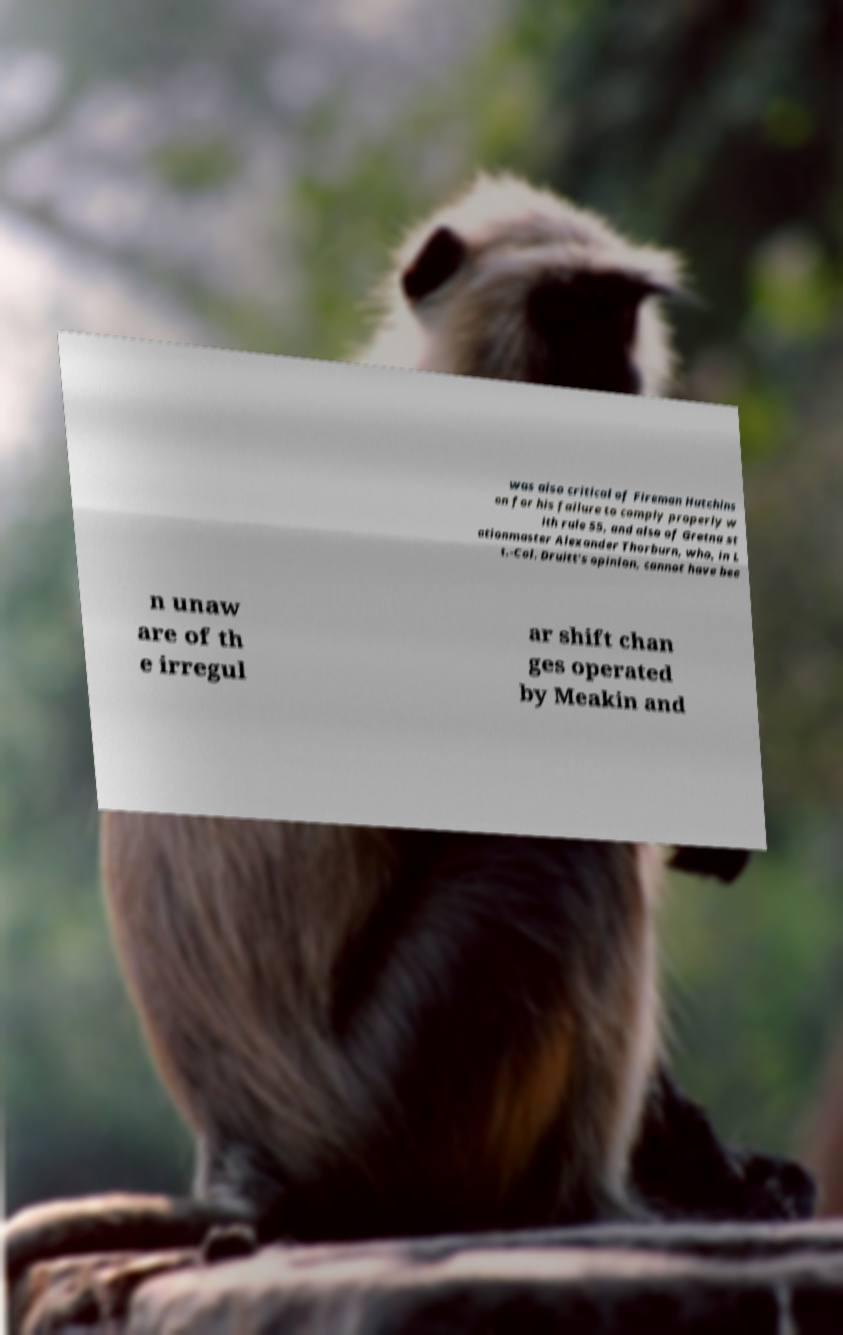Please identify and transcribe the text found in this image. was also critical of Fireman Hutchins on for his failure to comply properly w ith rule 55, and also of Gretna st ationmaster Alexander Thorburn, who, in L t.-Col. Druitt's opinion, cannot have bee n unaw are of th e irregul ar shift chan ges operated by Meakin and 